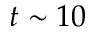Convert formula to latex. <formula><loc_0><loc_0><loc_500><loc_500>t \sim 1 0</formula> 